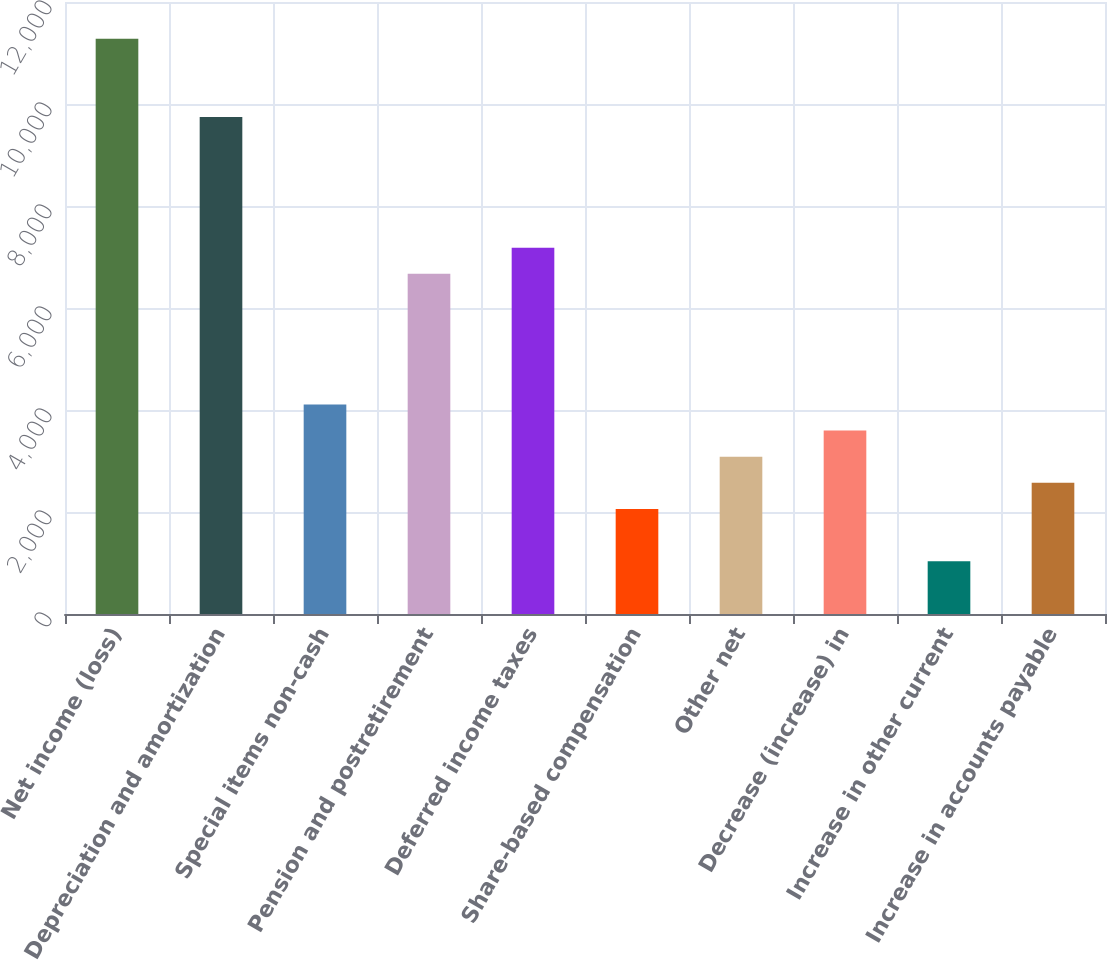Convert chart to OTSL. <chart><loc_0><loc_0><loc_500><loc_500><bar_chart><fcel>Net income (loss)<fcel>Depreciation and amortization<fcel>Special items non-cash<fcel>Pension and postretirement<fcel>Deferred income taxes<fcel>Share-based compensation<fcel>Other net<fcel>Decrease (increase) in<fcel>Increase in other current<fcel>Increase in accounts payable<nl><fcel>11281.6<fcel>9744.7<fcel>4109.4<fcel>6670.9<fcel>7183.2<fcel>2060.2<fcel>3084.8<fcel>3597.1<fcel>1035.6<fcel>2572.5<nl></chart> 